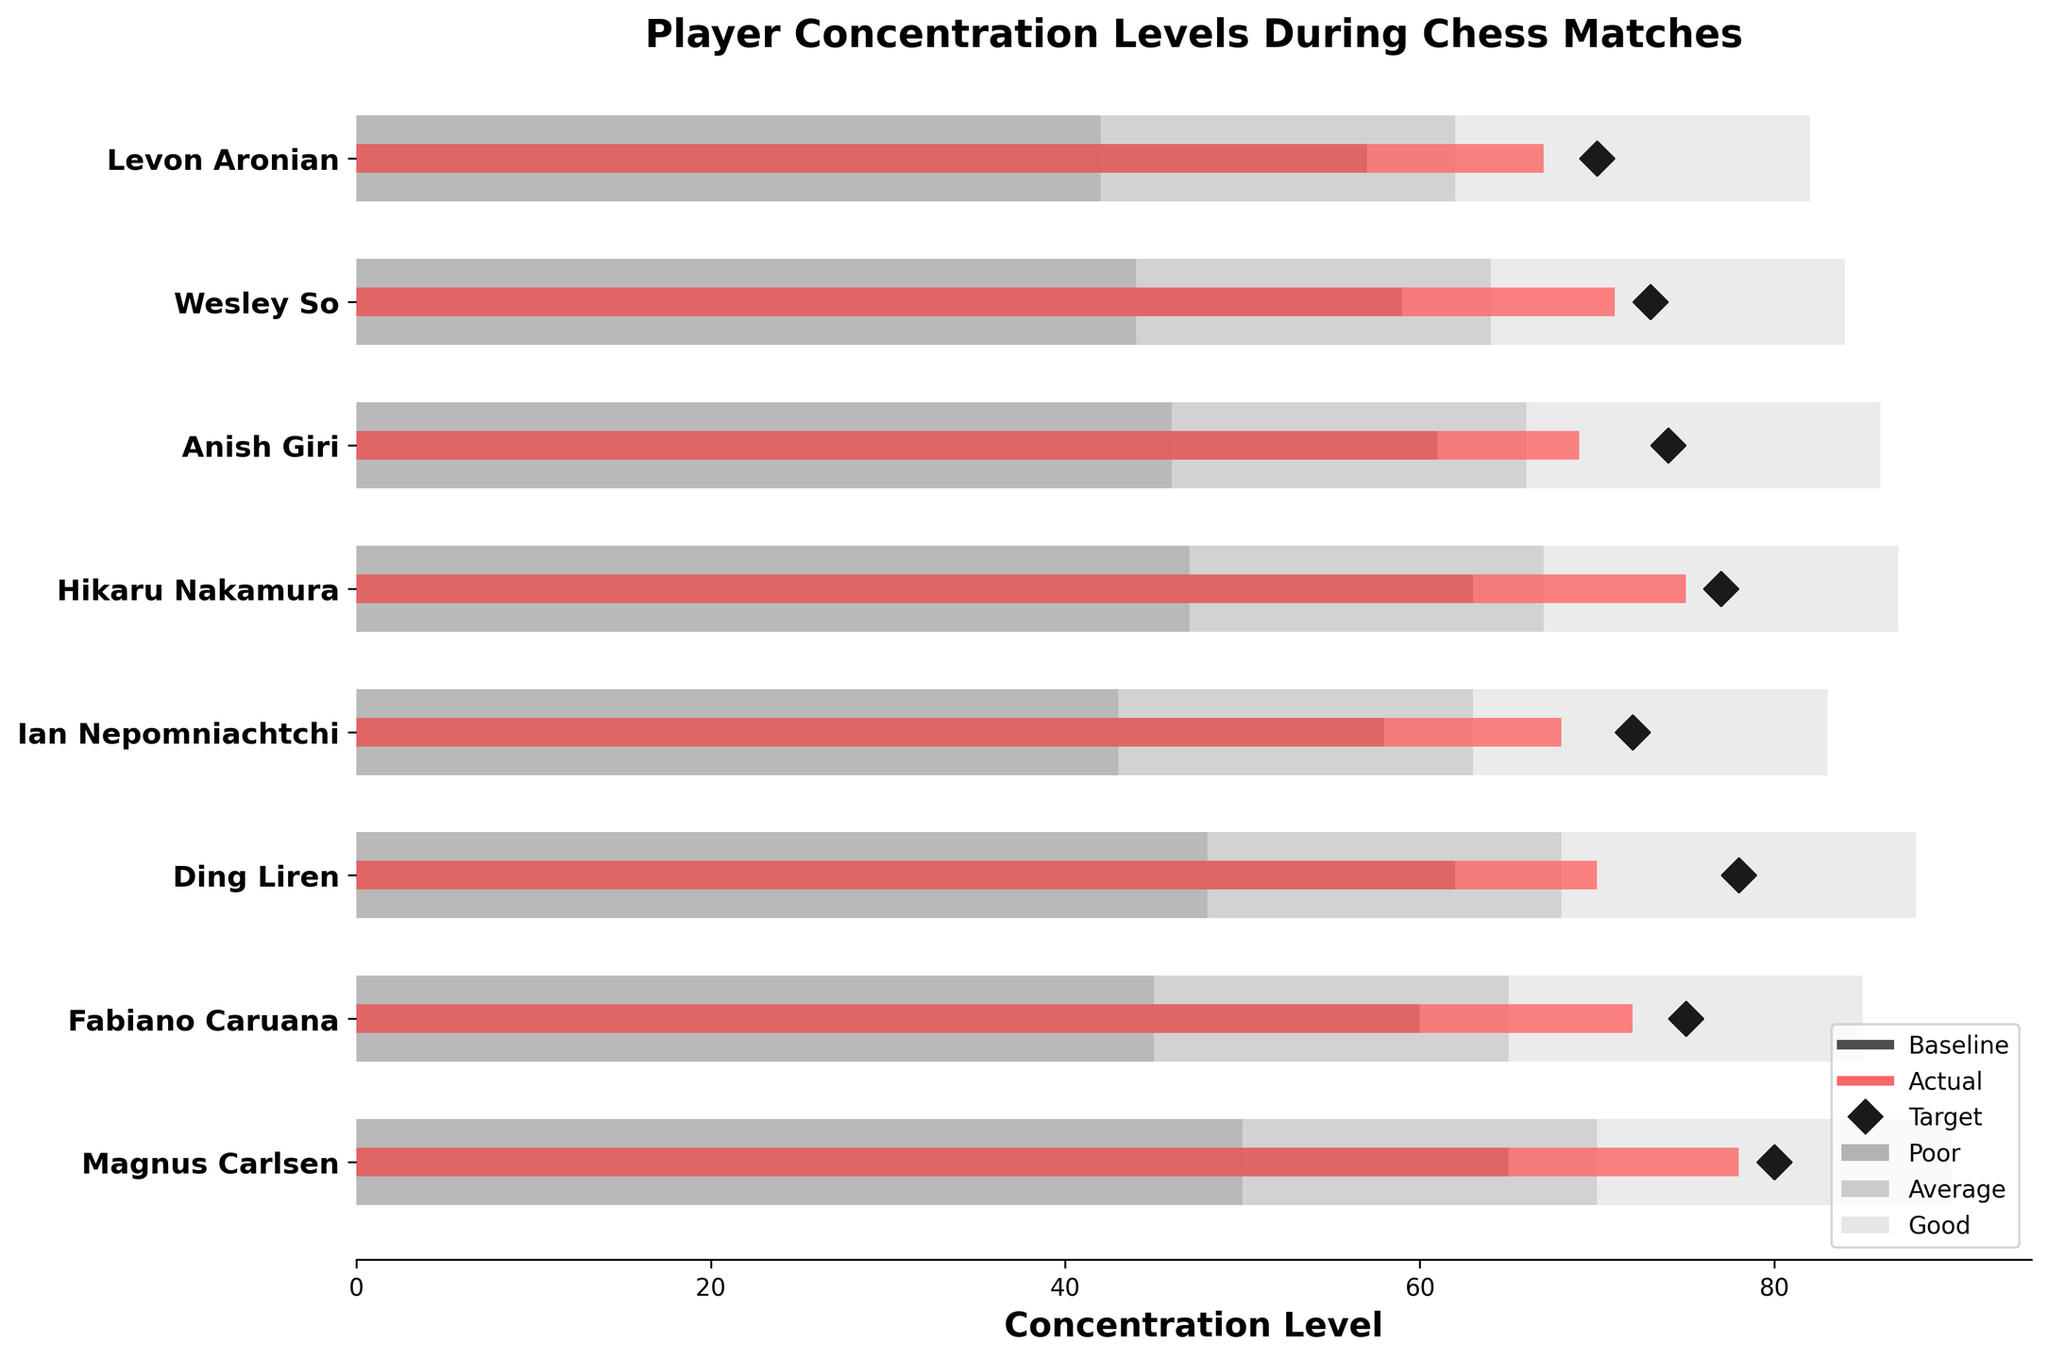What is the title of the chart? The title is displayed prominently at the top of the chart. Reading it directly reveals the answer.
Answer: Player Concentration Levels During Chess Matches Who has the highest actual concentration level? Compare the actual concentration levels for all players by examining the red bars and find the highest one.  Magnus Carlsen has the highest actual concentration level of 78.
Answer: Magnus Carlsen How does Fabiano Caruana's baseline concentration compare to his target concentration? Find Fabiano Caruana's baseline and target values. Fabiano's baseline concentration is 60, and his target concentration is 75.
Answer: The baseline is lower than the target What is the average actual concentration level of all players? Sum up all actual concentration levels and divide by the number of players. (78 + 72 + 70 + 68 + 75 + 69 + 71 + 67) / 8 = 570 / 8 = 71.25
Answer: 71.25 Which player has the smallest difference between their actual concentration and their target? Calculate the absolute differences between actual and target for each player: Magnus (2), Fabiano (3), Ding (8), Ian (4), Hikaru (2), Anish (5), Wesley (2), Levon (3). Magnus, Hikaru, and Wesley all have a difference of 2.
Answer: Magnus Carlsen, Hikaru Nakamura, and Wesley So Are there more players whose baseline concentration levels are in the "average" range compared to those in the "good" range? Compare the number of players whose baselines fall within the "average" range (65-70) to those in the "good" range (70-90). Magnus, Fabiano, Ding, Hikaru, Anish - are in the average range (65-70); Ian, Wesley, Levon - are in the good range (70-90).
Answer: More players are in the "average" range What is the median target concentration level? List all target concentration values in ascending order (70, 72, 73, 74, 75, 77, 78, 80) and find the middle one or the average of the two middle values. The median is the average of 74 and 75. (74+75)/2 = 74.5
Answer: 74.5 Which player falls in the "poor" concentration range for both baseline and actual levels? Check for players where both actual and baseline fall in respective "poor" ranges. Levon Aronian’s baseline (57) and actual (67) both fall within the range limits 50, 70, 90.
Answer: Levon Aronian Is any player's actual concentration level lower than their baseline? Check to see if any red bars (actual) are shorter than the grey bars (baseline) for each player. All players have an actual level greater than the baseline.
Answer: No 